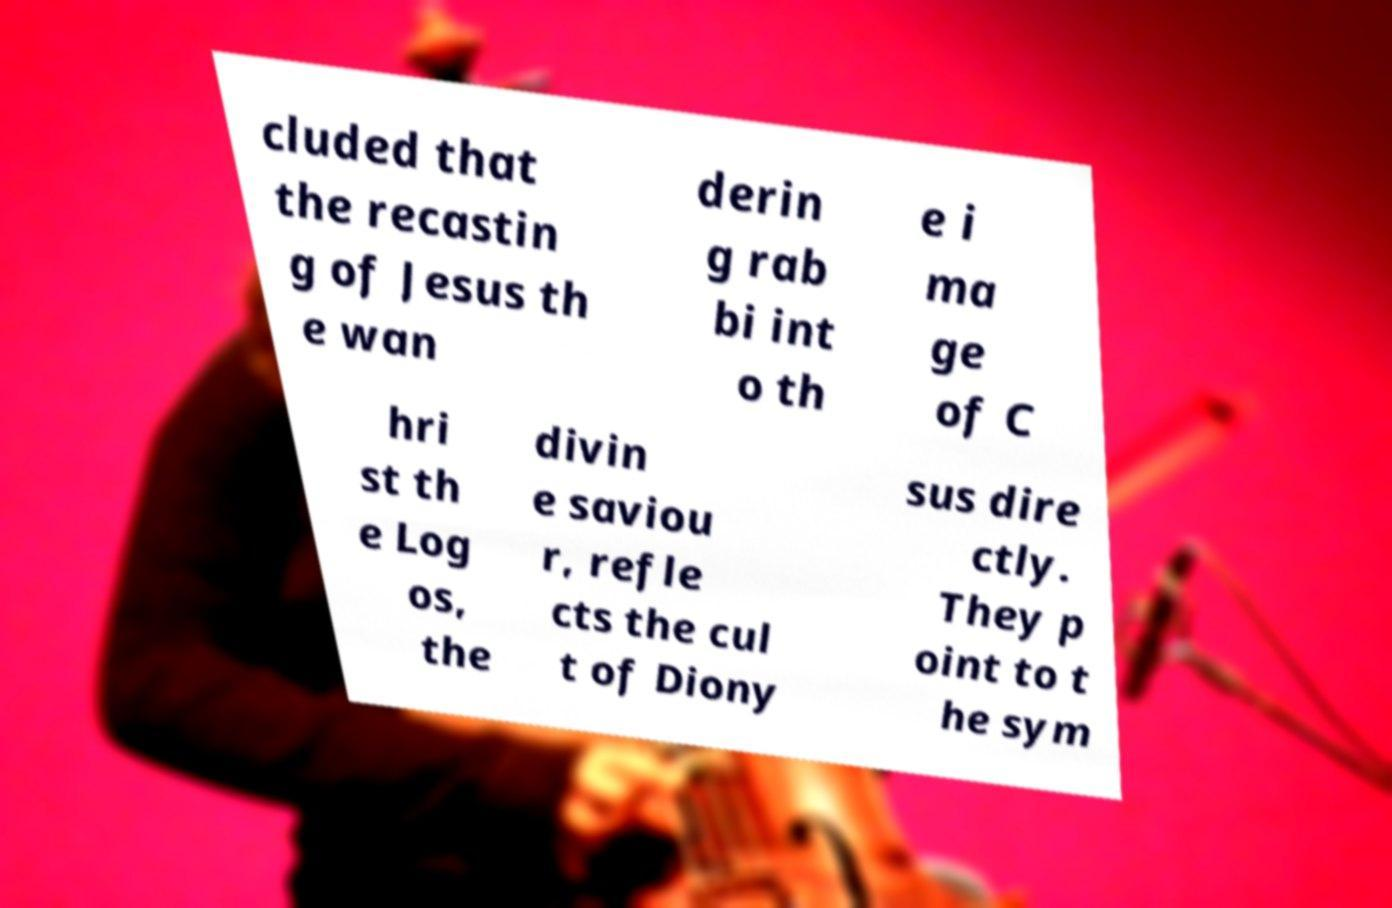Please read and relay the text visible in this image. What does it say? cluded that the recastin g of Jesus th e wan derin g rab bi int o th e i ma ge of C hri st th e Log os, the divin e saviou r, refle cts the cul t of Diony sus dire ctly. They p oint to t he sym 